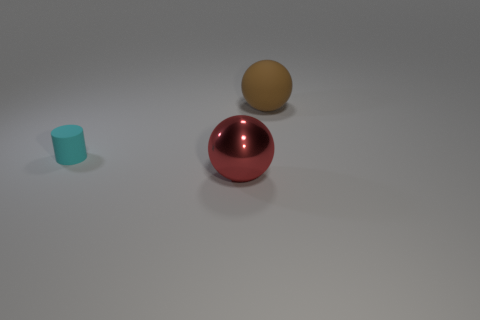There is a sphere that is behind the cyan cylinder; is there a large matte sphere that is behind it?
Provide a short and direct response. No. What material is the object that is both behind the red thing and right of the cyan matte thing?
Make the answer very short. Rubber. What is the color of the large thing that is left of the matte object behind the rubber thing on the left side of the red metallic thing?
Your response must be concise. Red. There is another sphere that is the same size as the matte sphere; what color is it?
Ensure brevity in your answer.  Red. There is a metal object; is it the same color as the ball to the right of the large metallic thing?
Offer a terse response. No. There is a large sphere in front of the big thing that is behind the small cyan object; what is its material?
Your answer should be very brief. Metal. How many big objects are both right of the metallic sphere and in front of the brown matte thing?
Offer a terse response. 0. What number of other things are there of the same size as the red sphere?
Provide a succinct answer. 1. There is a matte thing that is to the left of the red ball; is it the same shape as the brown object to the right of the cyan rubber cylinder?
Ensure brevity in your answer.  No. Are there any large shiny spheres left of the red metallic sphere?
Provide a short and direct response. No. 